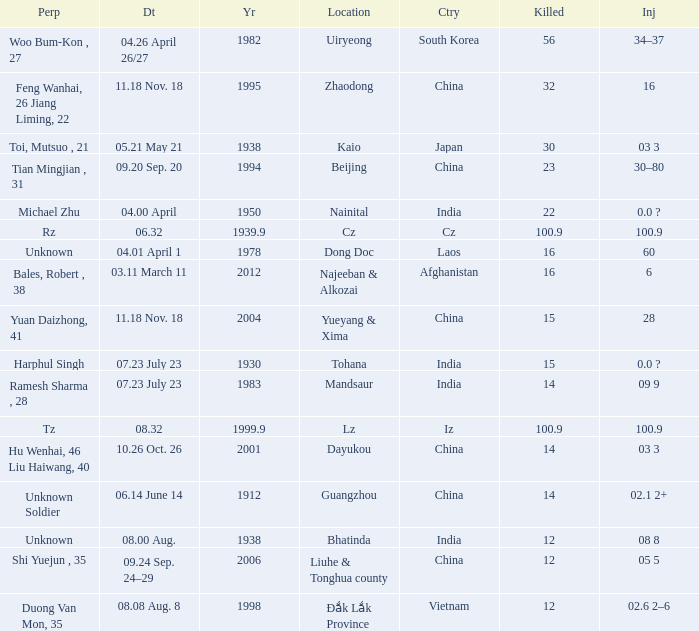9? Iz. 